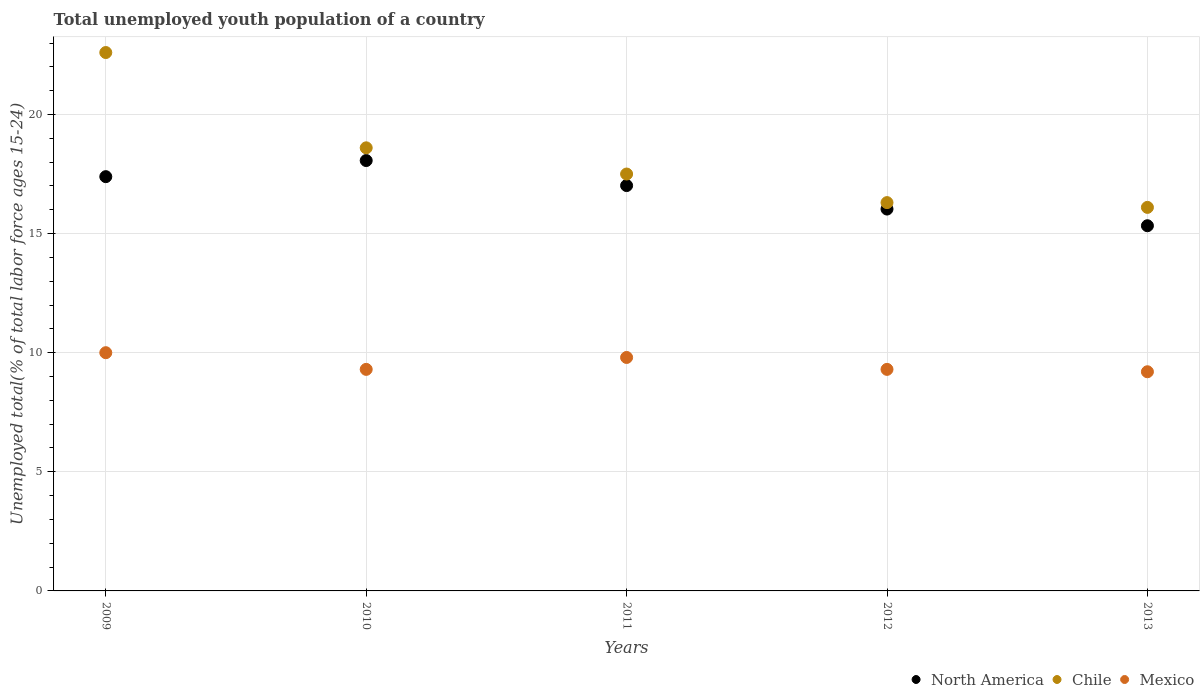How many different coloured dotlines are there?
Make the answer very short. 3. What is the percentage of total unemployed youth population of a country in North America in 2010?
Your response must be concise. 18.07. Across all years, what is the maximum percentage of total unemployed youth population of a country in North America?
Make the answer very short. 18.07. Across all years, what is the minimum percentage of total unemployed youth population of a country in Chile?
Make the answer very short. 16.1. What is the total percentage of total unemployed youth population of a country in Chile in the graph?
Offer a terse response. 91.1. What is the difference between the percentage of total unemployed youth population of a country in North America in 2009 and that in 2011?
Your answer should be compact. 0.37. What is the difference between the percentage of total unemployed youth population of a country in Chile in 2010 and the percentage of total unemployed youth population of a country in North America in 2009?
Keep it short and to the point. 1.21. What is the average percentage of total unemployed youth population of a country in Mexico per year?
Make the answer very short. 9.52. In the year 2013, what is the difference between the percentage of total unemployed youth population of a country in North America and percentage of total unemployed youth population of a country in Mexico?
Offer a terse response. 6.13. What is the ratio of the percentage of total unemployed youth population of a country in North America in 2009 to that in 2011?
Provide a succinct answer. 1.02. What is the difference between the highest and the second highest percentage of total unemployed youth population of a country in Chile?
Provide a succinct answer. 4. What is the difference between the highest and the lowest percentage of total unemployed youth population of a country in North America?
Provide a short and direct response. 2.74. Is it the case that in every year, the sum of the percentage of total unemployed youth population of a country in Chile and percentage of total unemployed youth population of a country in North America  is greater than the percentage of total unemployed youth population of a country in Mexico?
Ensure brevity in your answer.  Yes. Does the percentage of total unemployed youth population of a country in Mexico monotonically increase over the years?
Make the answer very short. No. How many dotlines are there?
Ensure brevity in your answer.  3. How many years are there in the graph?
Give a very brief answer. 5. Are the values on the major ticks of Y-axis written in scientific E-notation?
Make the answer very short. No. Does the graph contain grids?
Give a very brief answer. Yes. Where does the legend appear in the graph?
Provide a succinct answer. Bottom right. What is the title of the graph?
Keep it short and to the point. Total unemployed youth population of a country. What is the label or title of the X-axis?
Offer a very short reply. Years. What is the label or title of the Y-axis?
Give a very brief answer. Unemployed total(% of total labor force ages 15-24). What is the Unemployed total(% of total labor force ages 15-24) in North America in 2009?
Offer a terse response. 17.39. What is the Unemployed total(% of total labor force ages 15-24) in Chile in 2009?
Provide a short and direct response. 22.6. What is the Unemployed total(% of total labor force ages 15-24) in North America in 2010?
Provide a succinct answer. 18.07. What is the Unemployed total(% of total labor force ages 15-24) in Chile in 2010?
Offer a terse response. 18.6. What is the Unemployed total(% of total labor force ages 15-24) of Mexico in 2010?
Your answer should be compact. 9.3. What is the Unemployed total(% of total labor force ages 15-24) of North America in 2011?
Offer a terse response. 17.02. What is the Unemployed total(% of total labor force ages 15-24) in Mexico in 2011?
Your answer should be compact. 9.8. What is the Unemployed total(% of total labor force ages 15-24) of North America in 2012?
Your response must be concise. 16.03. What is the Unemployed total(% of total labor force ages 15-24) of Chile in 2012?
Offer a very short reply. 16.3. What is the Unemployed total(% of total labor force ages 15-24) in Mexico in 2012?
Provide a succinct answer. 9.3. What is the Unemployed total(% of total labor force ages 15-24) of North America in 2013?
Make the answer very short. 15.33. What is the Unemployed total(% of total labor force ages 15-24) of Chile in 2013?
Provide a short and direct response. 16.1. What is the Unemployed total(% of total labor force ages 15-24) of Mexico in 2013?
Your answer should be very brief. 9.2. Across all years, what is the maximum Unemployed total(% of total labor force ages 15-24) in North America?
Provide a succinct answer. 18.07. Across all years, what is the maximum Unemployed total(% of total labor force ages 15-24) in Chile?
Your answer should be compact. 22.6. Across all years, what is the minimum Unemployed total(% of total labor force ages 15-24) in North America?
Keep it short and to the point. 15.33. Across all years, what is the minimum Unemployed total(% of total labor force ages 15-24) of Chile?
Your answer should be compact. 16.1. Across all years, what is the minimum Unemployed total(% of total labor force ages 15-24) in Mexico?
Make the answer very short. 9.2. What is the total Unemployed total(% of total labor force ages 15-24) of North America in the graph?
Make the answer very short. 83.83. What is the total Unemployed total(% of total labor force ages 15-24) in Chile in the graph?
Give a very brief answer. 91.1. What is the total Unemployed total(% of total labor force ages 15-24) of Mexico in the graph?
Provide a succinct answer. 47.6. What is the difference between the Unemployed total(% of total labor force ages 15-24) in North America in 2009 and that in 2010?
Keep it short and to the point. -0.68. What is the difference between the Unemployed total(% of total labor force ages 15-24) in North America in 2009 and that in 2011?
Offer a very short reply. 0.37. What is the difference between the Unemployed total(% of total labor force ages 15-24) of North America in 2009 and that in 2012?
Your answer should be compact. 1.36. What is the difference between the Unemployed total(% of total labor force ages 15-24) in Chile in 2009 and that in 2012?
Make the answer very short. 6.3. What is the difference between the Unemployed total(% of total labor force ages 15-24) of North America in 2009 and that in 2013?
Make the answer very short. 2.06. What is the difference between the Unemployed total(% of total labor force ages 15-24) in Chile in 2009 and that in 2013?
Your answer should be compact. 6.5. What is the difference between the Unemployed total(% of total labor force ages 15-24) of Mexico in 2009 and that in 2013?
Ensure brevity in your answer.  0.8. What is the difference between the Unemployed total(% of total labor force ages 15-24) in North America in 2010 and that in 2011?
Your answer should be compact. 1.05. What is the difference between the Unemployed total(% of total labor force ages 15-24) of North America in 2010 and that in 2012?
Provide a succinct answer. 2.04. What is the difference between the Unemployed total(% of total labor force ages 15-24) in Chile in 2010 and that in 2012?
Offer a very short reply. 2.3. What is the difference between the Unemployed total(% of total labor force ages 15-24) of Mexico in 2010 and that in 2012?
Your response must be concise. 0. What is the difference between the Unemployed total(% of total labor force ages 15-24) of North America in 2010 and that in 2013?
Offer a terse response. 2.74. What is the difference between the Unemployed total(% of total labor force ages 15-24) of Mexico in 2010 and that in 2013?
Your answer should be very brief. 0.1. What is the difference between the Unemployed total(% of total labor force ages 15-24) of North America in 2011 and that in 2012?
Give a very brief answer. 0.99. What is the difference between the Unemployed total(% of total labor force ages 15-24) in Chile in 2011 and that in 2012?
Provide a succinct answer. 1.2. What is the difference between the Unemployed total(% of total labor force ages 15-24) in Mexico in 2011 and that in 2012?
Your answer should be very brief. 0.5. What is the difference between the Unemployed total(% of total labor force ages 15-24) of North America in 2011 and that in 2013?
Your response must be concise. 1.69. What is the difference between the Unemployed total(% of total labor force ages 15-24) in Mexico in 2011 and that in 2013?
Provide a short and direct response. 0.6. What is the difference between the Unemployed total(% of total labor force ages 15-24) in North America in 2012 and that in 2013?
Provide a succinct answer. 0.7. What is the difference between the Unemployed total(% of total labor force ages 15-24) of Chile in 2012 and that in 2013?
Your answer should be compact. 0.2. What is the difference between the Unemployed total(% of total labor force ages 15-24) of Mexico in 2012 and that in 2013?
Make the answer very short. 0.1. What is the difference between the Unemployed total(% of total labor force ages 15-24) in North America in 2009 and the Unemployed total(% of total labor force ages 15-24) in Chile in 2010?
Provide a succinct answer. -1.21. What is the difference between the Unemployed total(% of total labor force ages 15-24) of North America in 2009 and the Unemployed total(% of total labor force ages 15-24) of Mexico in 2010?
Provide a succinct answer. 8.09. What is the difference between the Unemployed total(% of total labor force ages 15-24) of North America in 2009 and the Unemployed total(% of total labor force ages 15-24) of Chile in 2011?
Provide a short and direct response. -0.11. What is the difference between the Unemployed total(% of total labor force ages 15-24) of North America in 2009 and the Unemployed total(% of total labor force ages 15-24) of Mexico in 2011?
Make the answer very short. 7.59. What is the difference between the Unemployed total(% of total labor force ages 15-24) of North America in 2009 and the Unemployed total(% of total labor force ages 15-24) of Chile in 2012?
Make the answer very short. 1.09. What is the difference between the Unemployed total(% of total labor force ages 15-24) of North America in 2009 and the Unemployed total(% of total labor force ages 15-24) of Mexico in 2012?
Your response must be concise. 8.09. What is the difference between the Unemployed total(% of total labor force ages 15-24) of Chile in 2009 and the Unemployed total(% of total labor force ages 15-24) of Mexico in 2012?
Offer a very short reply. 13.3. What is the difference between the Unemployed total(% of total labor force ages 15-24) of North America in 2009 and the Unemployed total(% of total labor force ages 15-24) of Chile in 2013?
Provide a succinct answer. 1.29. What is the difference between the Unemployed total(% of total labor force ages 15-24) in North America in 2009 and the Unemployed total(% of total labor force ages 15-24) in Mexico in 2013?
Offer a terse response. 8.19. What is the difference between the Unemployed total(% of total labor force ages 15-24) of North America in 2010 and the Unemployed total(% of total labor force ages 15-24) of Chile in 2011?
Make the answer very short. 0.57. What is the difference between the Unemployed total(% of total labor force ages 15-24) of North America in 2010 and the Unemployed total(% of total labor force ages 15-24) of Mexico in 2011?
Keep it short and to the point. 8.27. What is the difference between the Unemployed total(% of total labor force ages 15-24) in Chile in 2010 and the Unemployed total(% of total labor force ages 15-24) in Mexico in 2011?
Offer a terse response. 8.8. What is the difference between the Unemployed total(% of total labor force ages 15-24) of North America in 2010 and the Unemployed total(% of total labor force ages 15-24) of Chile in 2012?
Your response must be concise. 1.77. What is the difference between the Unemployed total(% of total labor force ages 15-24) of North America in 2010 and the Unemployed total(% of total labor force ages 15-24) of Mexico in 2012?
Your response must be concise. 8.77. What is the difference between the Unemployed total(% of total labor force ages 15-24) in Chile in 2010 and the Unemployed total(% of total labor force ages 15-24) in Mexico in 2012?
Provide a short and direct response. 9.3. What is the difference between the Unemployed total(% of total labor force ages 15-24) in North America in 2010 and the Unemployed total(% of total labor force ages 15-24) in Chile in 2013?
Provide a succinct answer. 1.97. What is the difference between the Unemployed total(% of total labor force ages 15-24) of North America in 2010 and the Unemployed total(% of total labor force ages 15-24) of Mexico in 2013?
Provide a succinct answer. 8.87. What is the difference between the Unemployed total(% of total labor force ages 15-24) of North America in 2011 and the Unemployed total(% of total labor force ages 15-24) of Chile in 2012?
Offer a very short reply. 0.72. What is the difference between the Unemployed total(% of total labor force ages 15-24) in North America in 2011 and the Unemployed total(% of total labor force ages 15-24) in Mexico in 2012?
Provide a short and direct response. 7.72. What is the difference between the Unemployed total(% of total labor force ages 15-24) of North America in 2011 and the Unemployed total(% of total labor force ages 15-24) of Chile in 2013?
Keep it short and to the point. 0.92. What is the difference between the Unemployed total(% of total labor force ages 15-24) of North America in 2011 and the Unemployed total(% of total labor force ages 15-24) of Mexico in 2013?
Your answer should be compact. 7.82. What is the difference between the Unemployed total(% of total labor force ages 15-24) of Chile in 2011 and the Unemployed total(% of total labor force ages 15-24) of Mexico in 2013?
Give a very brief answer. 8.3. What is the difference between the Unemployed total(% of total labor force ages 15-24) of North America in 2012 and the Unemployed total(% of total labor force ages 15-24) of Chile in 2013?
Your answer should be very brief. -0.07. What is the difference between the Unemployed total(% of total labor force ages 15-24) in North America in 2012 and the Unemployed total(% of total labor force ages 15-24) in Mexico in 2013?
Offer a terse response. 6.83. What is the difference between the Unemployed total(% of total labor force ages 15-24) in Chile in 2012 and the Unemployed total(% of total labor force ages 15-24) in Mexico in 2013?
Your answer should be compact. 7.1. What is the average Unemployed total(% of total labor force ages 15-24) of North America per year?
Offer a very short reply. 16.77. What is the average Unemployed total(% of total labor force ages 15-24) of Chile per year?
Ensure brevity in your answer.  18.22. What is the average Unemployed total(% of total labor force ages 15-24) in Mexico per year?
Provide a short and direct response. 9.52. In the year 2009, what is the difference between the Unemployed total(% of total labor force ages 15-24) in North America and Unemployed total(% of total labor force ages 15-24) in Chile?
Your answer should be very brief. -5.21. In the year 2009, what is the difference between the Unemployed total(% of total labor force ages 15-24) in North America and Unemployed total(% of total labor force ages 15-24) in Mexico?
Offer a very short reply. 7.39. In the year 2009, what is the difference between the Unemployed total(% of total labor force ages 15-24) of Chile and Unemployed total(% of total labor force ages 15-24) of Mexico?
Provide a succinct answer. 12.6. In the year 2010, what is the difference between the Unemployed total(% of total labor force ages 15-24) in North America and Unemployed total(% of total labor force ages 15-24) in Chile?
Ensure brevity in your answer.  -0.53. In the year 2010, what is the difference between the Unemployed total(% of total labor force ages 15-24) of North America and Unemployed total(% of total labor force ages 15-24) of Mexico?
Make the answer very short. 8.77. In the year 2011, what is the difference between the Unemployed total(% of total labor force ages 15-24) in North America and Unemployed total(% of total labor force ages 15-24) in Chile?
Give a very brief answer. -0.48. In the year 2011, what is the difference between the Unemployed total(% of total labor force ages 15-24) in North America and Unemployed total(% of total labor force ages 15-24) in Mexico?
Offer a very short reply. 7.22. In the year 2011, what is the difference between the Unemployed total(% of total labor force ages 15-24) in Chile and Unemployed total(% of total labor force ages 15-24) in Mexico?
Offer a very short reply. 7.7. In the year 2012, what is the difference between the Unemployed total(% of total labor force ages 15-24) of North America and Unemployed total(% of total labor force ages 15-24) of Chile?
Make the answer very short. -0.27. In the year 2012, what is the difference between the Unemployed total(% of total labor force ages 15-24) in North America and Unemployed total(% of total labor force ages 15-24) in Mexico?
Offer a terse response. 6.73. In the year 2012, what is the difference between the Unemployed total(% of total labor force ages 15-24) in Chile and Unemployed total(% of total labor force ages 15-24) in Mexico?
Offer a terse response. 7. In the year 2013, what is the difference between the Unemployed total(% of total labor force ages 15-24) in North America and Unemployed total(% of total labor force ages 15-24) in Chile?
Ensure brevity in your answer.  -0.77. In the year 2013, what is the difference between the Unemployed total(% of total labor force ages 15-24) in North America and Unemployed total(% of total labor force ages 15-24) in Mexico?
Your answer should be compact. 6.13. In the year 2013, what is the difference between the Unemployed total(% of total labor force ages 15-24) in Chile and Unemployed total(% of total labor force ages 15-24) in Mexico?
Offer a terse response. 6.9. What is the ratio of the Unemployed total(% of total labor force ages 15-24) of North America in 2009 to that in 2010?
Give a very brief answer. 0.96. What is the ratio of the Unemployed total(% of total labor force ages 15-24) of Chile in 2009 to that in 2010?
Give a very brief answer. 1.22. What is the ratio of the Unemployed total(% of total labor force ages 15-24) of Mexico in 2009 to that in 2010?
Offer a terse response. 1.08. What is the ratio of the Unemployed total(% of total labor force ages 15-24) of Chile in 2009 to that in 2011?
Offer a very short reply. 1.29. What is the ratio of the Unemployed total(% of total labor force ages 15-24) in Mexico in 2009 to that in 2011?
Offer a terse response. 1.02. What is the ratio of the Unemployed total(% of total labor force ages 15-24) in North America in 2009 to that in 2012?
Provide a succinct answer. 1.08. What is the ratio of the Unemployed total(% of total labor force ages 15-24) in Chile in 2009 to that in 2012?
Your answer should be compact. 1.39. What is the ratio of the Unemployed total(% of total labor force ages 15-24) of Mexico in 2009 to that in 2012?
Your answer should be compact. 1.08. What is the ratio of the Unemployed total(% of total labor force ages 15-24) of North America in 2009 to that in 2013?
Ensure brevity in your answer.  1.13. What is the ratio of the Unemployed total(% of total labor force ages 15-24) in Chile in 2009 to that in 2013?
Ensure brevity in your answer.  1.4. What is the ratio of the Unemployed total(% of total labor force ages 15-24) of Mexico in 2009 to that in 2013?
Keep it short and to the point. 1.09. What is the ratio of the Unemployed total(% of total labor force ages 15-24) of North America in 2010 to that in 2011?
Ensure brevity in your answer.  1.06. What is the ratio of the Unemployed total(% of total labor force ages 15-24) in Chile in 2010 to that in 2011?
Keep it short and to the point. 1.06. What is the ratio of the Unemployed total(% of total labor force ages 15-24) in Mexico in 2010 to that in 2011?
Make the answer very short. 0.95. What is the ratio of the Unemployed total(% of total labor force ages 15-24) of North America in 2010 to that in 2012?
Provide a short and direct response. 1.13. What is the ratio of the Unemployed total(% of total labor force ages 15-24) in Chile in 2010 to that in 2012?
Provide a short and direct response. 1.14. What is the ratio of the Unemployed total(% of total labor force ages 15-24) in North America in 2010 to that in 2013?
Offer a very short reply. 1.18. What is the ratio of the Unemployed total(% of total labor force ages 15-24) in Chile in 2010 to that in 2013?
Keep it short and to the point. 1.16. What is the ratio of the Unemployed total(% of total labor force ages 15-24) of Mexico in 2010 to that in 2013?
Ensure brevity in your answer.  1.01. What is the ratio of the Unemployed total(% of total labor force ages 15-24) in North America in 2011 to that in 2012?
Make the answer very short. 1.06. What is the ratio of the Unemployed total(% of total labor force ages 15-24) of Chile in 2011 to that in 2012?
Your response must be concise. 1.07. What is the ratio of the Unemployed total(% of total labor force ages 15-24) of Mexico in 2011 to that in 2012?
Offer a very short reply. 1.05. What is the ratio of the Unemployed total(% of total labor force ages 15-24) of North America in 2011 to that in 2013?
Keep it short and to the point. 1.11. What is the ratio of the Unemployed total(% of total labor force ages 15-24) in Chile in 2011 to that in 2013?
Offer a very short reply. 1.09. What is the ratio of the Unemployed total(% of total labor force ages 15-24) of Mexico in 2011 to that in 2013?
Provide a succinct answer. 1.07. What is the ratio of the Unemployed total(% of total labor force ages 15-24) of North America in 2012 to that in 2013?
Offer a terse response. 1.05. What is the ratio of the Unemployed total(% of total labor force ages 15-24) of Chile in 2012 to that in 2013?
Your answer should be compact. 1.01. What is the ratio of the Unemployed total(% of total labor force ages 15-24) of Mexico in 2012 to that in 2013?
Offer a very short reply. 1.01. What is the difference between the highest and the second highest Unemployed total(% of total labor force ages 15-24) in North America?
Provide a succinct answer. 0.68. What is the difference between the highest and the lowest Unemployed total(% of total labor force ages 15-24) in North America?
Give a very brief answer. 2.74. What is the difference between the highest and the lowest Unemployed total(% of total labor force ages 15-24) in Chile?
Offer a terse response. 6.5. What is the difference between the highest and the lowest Unemployed total(% of total labor force ages 15-24) of Mexico?
Your answer should be very brief. 0.8. 